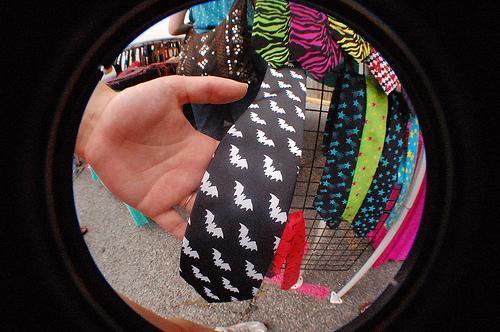How many people in picture?
Give a very brief answer. 2. 